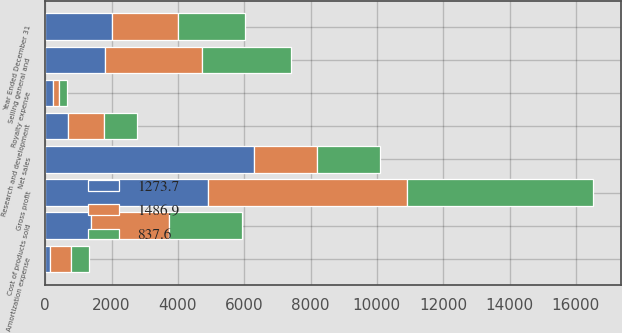<chart> <loc_0><loc_0><loc_500><loc_500><stacked_bar_chart><ecel><fcel>Year Ended December 31<fcel>Net sales<fcel>Cost of products sold<fcel>Gross profit<fcel>Selling general and<fcel>Research and development<fcel>Royalty expense<fcel>Amortization expense<nl><fcel>1486.9<fcel>2007<fcel>1909.5<fcel>2342<fcel>6015<fcel>2909<fcel>1091<fcel>202<fcel>641<nl><fcel>837.6<fcel>2006<fcel>1909.5<fcel>2207<fcel>5614<fcel>2675<fcel>1008<fcel>231<fcel>530<nl><fcel>1273.7<fcel>2005<fcel>6283<fcel>1386<fcel>4897<fcel>1814<fcel>680<fcel>227<fcel>152<nl></chart> 